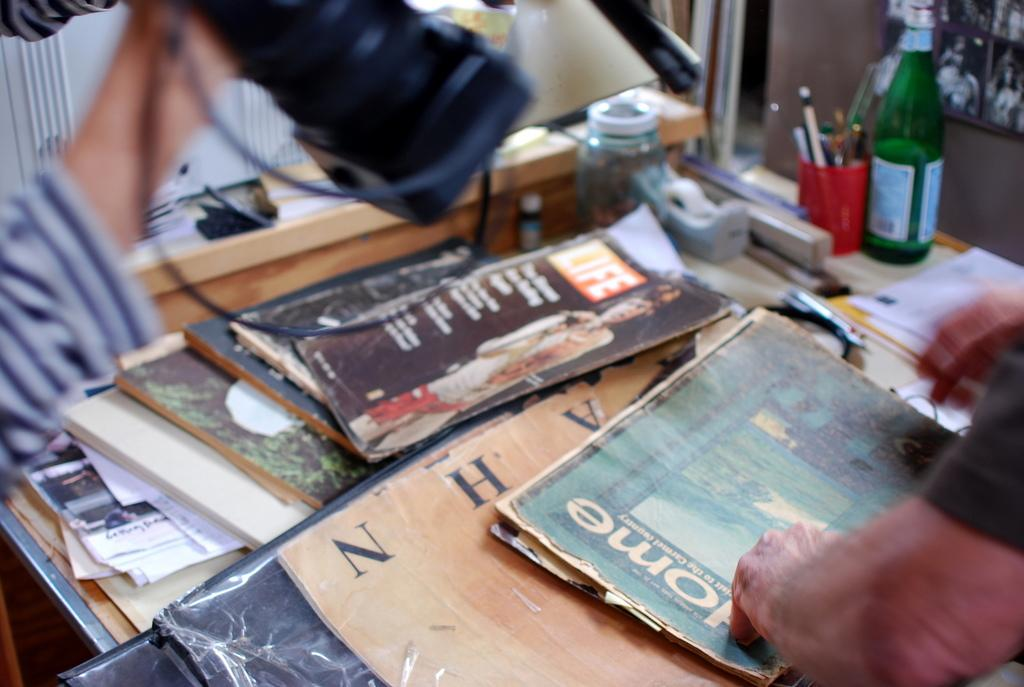<image>
Summarize the visual content of the image. An issue of Life magazine sits on a table along with other old books and magazines. 